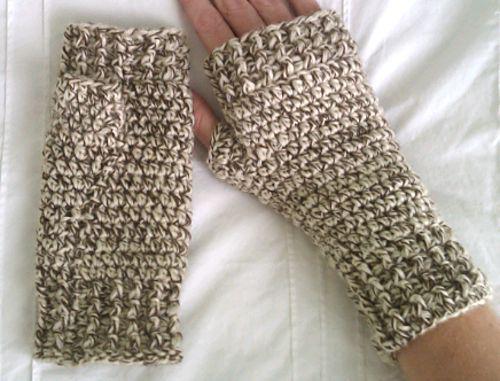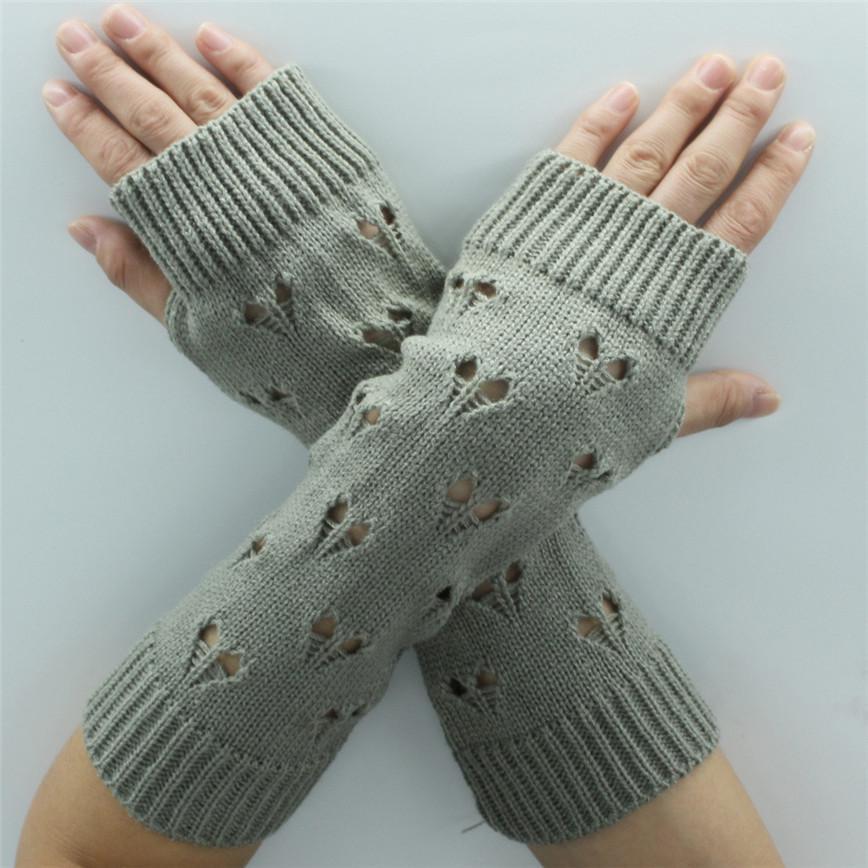The first image is the image on the left, the second image is the image on the right. Given the left and right images, does the statement "Each image shows exactly one pair of """"mittens"""", and one features a pair with a rounded flap and half-fingers." hold true? Answer yes or no. No. The first image is the image on the left, the second image is the image on the right. Given the left and right images, does the statement "The gloves in one of the images is not being worn." hold true? Answer yes or no. No. 